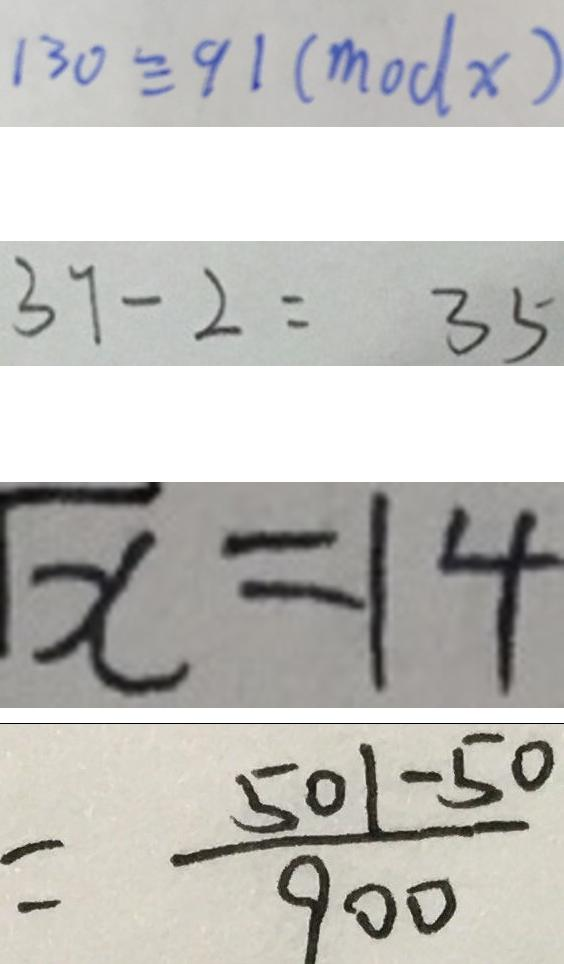Convert formula to latex. <formula><loc_0><loc_0><loc_500><loc_500>1 3 0 \equiv 9 1 ( m o d x ) 
 3 7 - 2 = 3 5 
 \sqrt { x } = 1 4 
 = \frac { 5 0 1 - 5 0 } { 9 0 0 }</formula> 